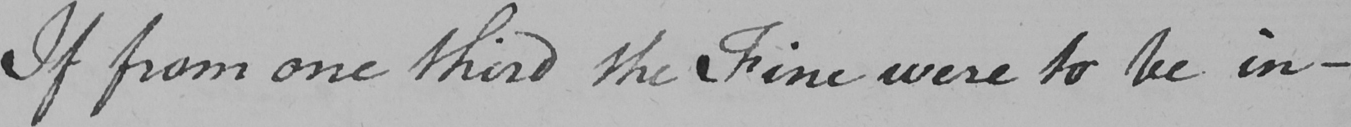Can you read and transcribe this handwriting? If from one third the Fine were to be in- 